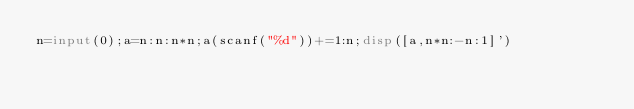Convert code to text. <code><loc_0><loc_0><loc_500><loc_500><_Octave_>n=input(0);a=n:n:n*n;a(scanf("%d"))+=1:n;disp([a,n*n:-n:1]')</code> 